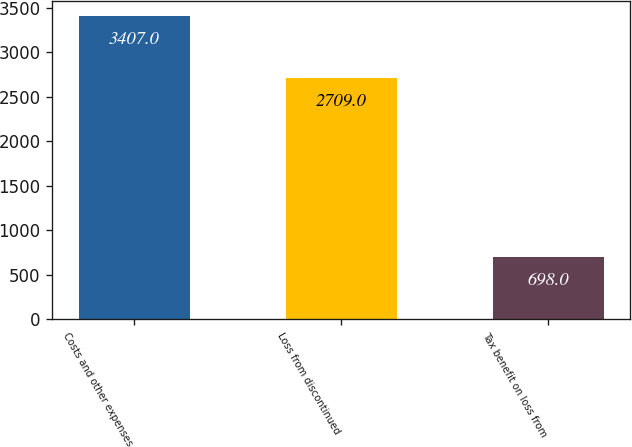Convert chart. <chart><loc_0><loc_0><loc_500><loc_500><bar_chart><fcel>Costs and other expenses<fcel>Loss from discontinued<fcel>Tax benefit on loss from<nl><fcel>3407<fcel>2709<fcel>698<nl></chart> 